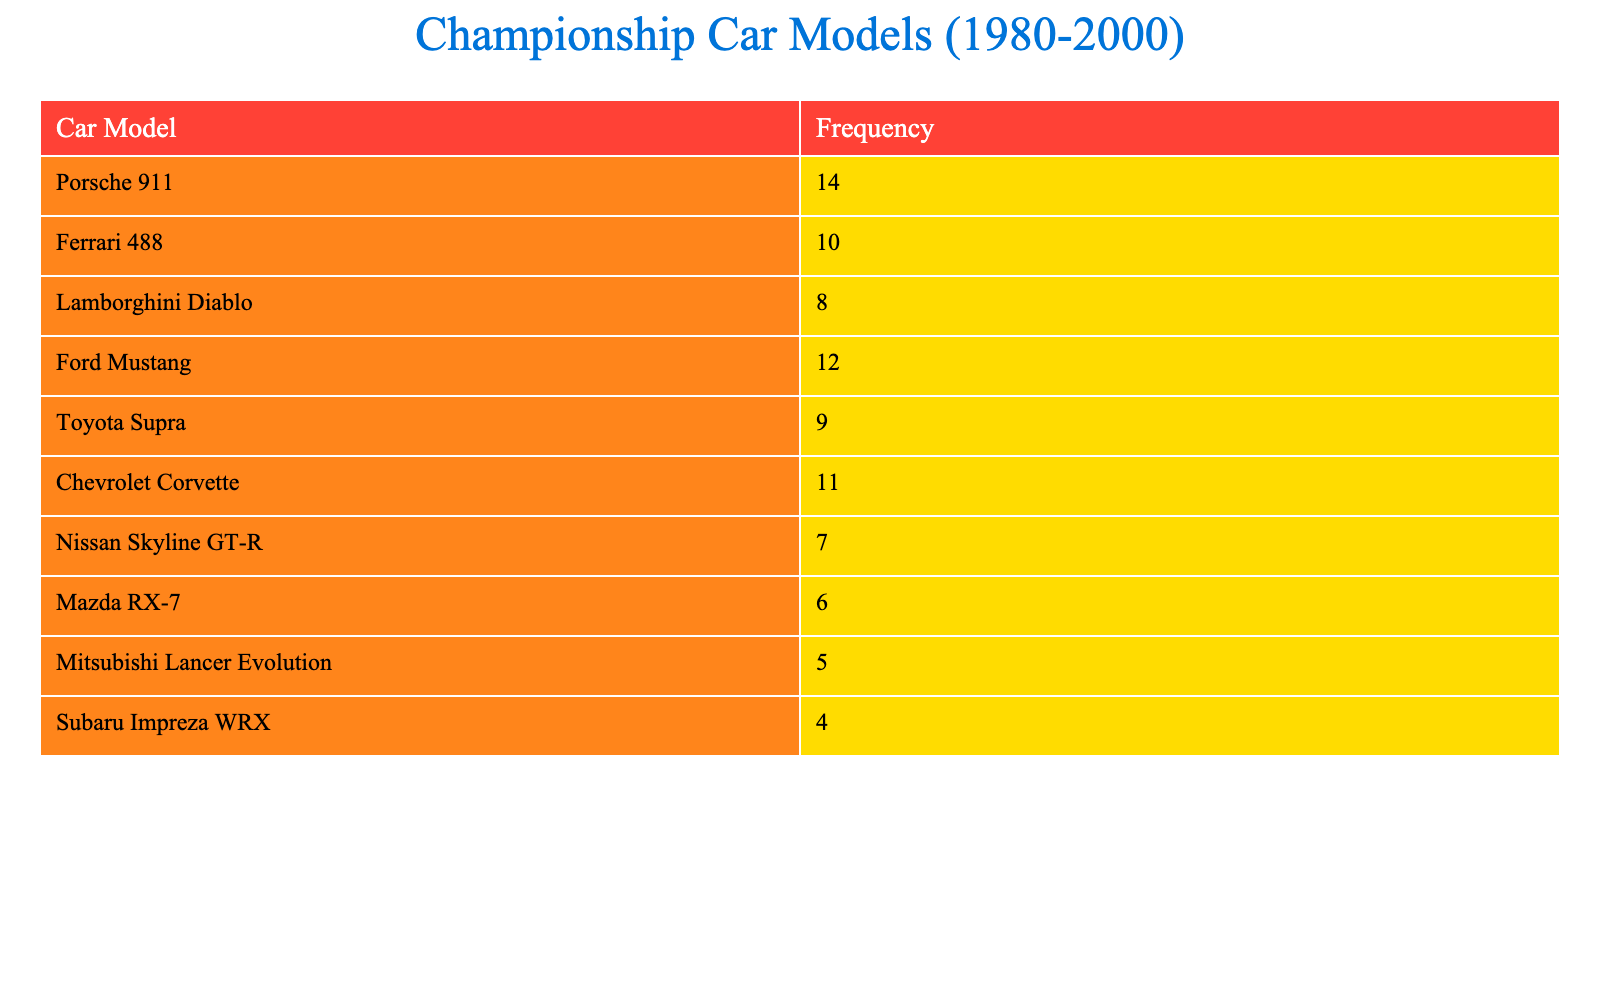What car model has the highest frequency in the championships? The data shows that the Porsche 911 has a frequency of 14, which is the highest among all listed car models.
Answer: Porsche 911 What is the frequency of the Lamborghini Diablo? From the table, the Lamborghini Diablo has a frequency of 8.
Answer: 8 How many car models have a frequency greater than 10? The table lists three car models with frequencies greater than 10: Porsche 911 (14), Ford Mustang (12), and Chevrolet Corvette (11), totaling three models.
Answer: 3 What is the total frequency of all car models combined? To find the total frequency, add the frequencies of all car models: 14 + 10 + 8 + 12 + 9 + 11 + 7 + 6 + 5 + 4 = 88.
Answer: 88 Is the frequency of the Toyota Supra higher than that of the Nissan Skyline GT-R? The frequency of the Toyota Supra is 9, while the Nissan Skyline GT-R has a frequency of 7. Since 9 is greater than 7, the statement is true.
Answer: Yes Which model has the lowest frequency in the championships? The Mazda RX-7 has a frequency of 6, which is the lowest among the listed models.
Answer: Mazda RX-7 What is the difference in frequency between the Ford Mustang and the Ferrari 488? The frequency of the Ford Mustang is 12 and for the Ferrari 488 is 10. The difference is 12 - 10 = 2.
Answer: 2 How many car models have a frequency of less than 7? The table shows two car models with frequencies less than 7: Nissan Skyline GT-R (7) is not counted, but Mazda RX-7 (6) and Mitsubishi Lancer Evolution (5) do fall below 7. Hence, there are two models.
Answer: 2 What is the average frequency of the car models listed? To calculate the average frequency, sum all the frequencies (88) and divide by the total number of car models (10). The average is 88/10 = 8.8.
Answer: 8.8 